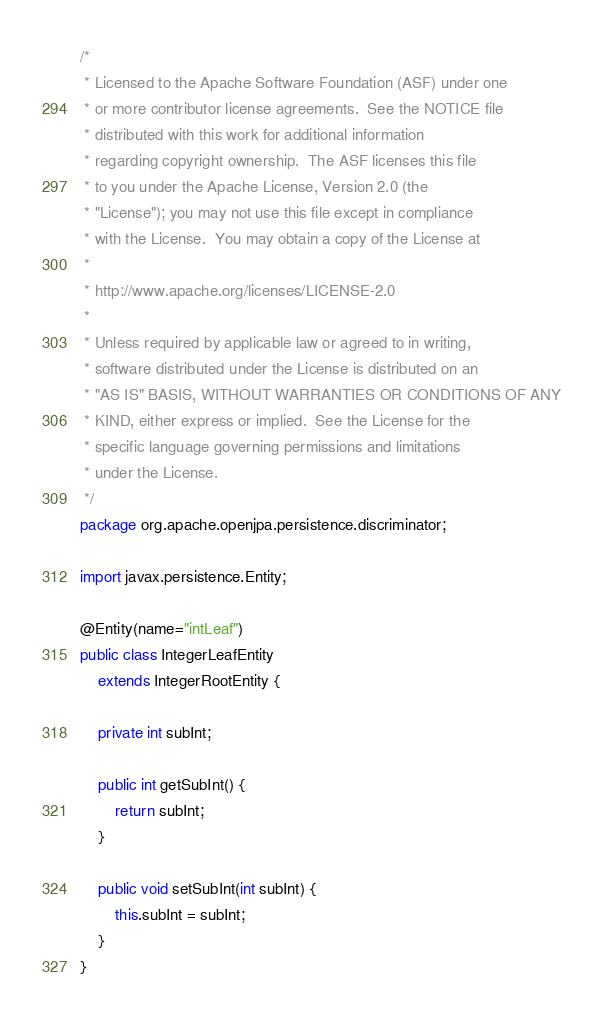<code> <loc_0><loc_0><loc_500><loc_500><_Java_>/*
 * Licensed to the Apache Software Foundation (ASF) under one
 * or more contributor license agreements.  See the NOTICE file
 * distributed with this work for additional information
 * regarding copyright ownership.  The ASF licenses this file
 * to you under the Apache License, Version 2.0 (the
 * "License"); you may not use this file except in compliance
 * with the License.  You may obtain a copy of the License at
 *
 * http://www.apache.org/licenses/LICENSE-2.0
 *
 * Unless required by applicable law or agreed to in writing,
 * software distributed under the License is distributed on an
 * "AS IS" BASIS, WITHOUT WARRANTIES OR CONDITIONS OF ANY
 * KIND, either express or implied.  See the License for the
 * specific language governing permissions and limitations
 * under the License.
 */
package org.apache.openjpa.persistence.discriminator;

import javax.persistence.Entity;

@Entity(name="intLeaf")
public class IntegerLeafEntity
    extends IntegerRootEntity {

    private int subInt;

    public int getSubInt() {
        return subInt;
    }

    public void setSubInt(int subInt) {
        this.subInt = subInt;
    }
}
</code> 